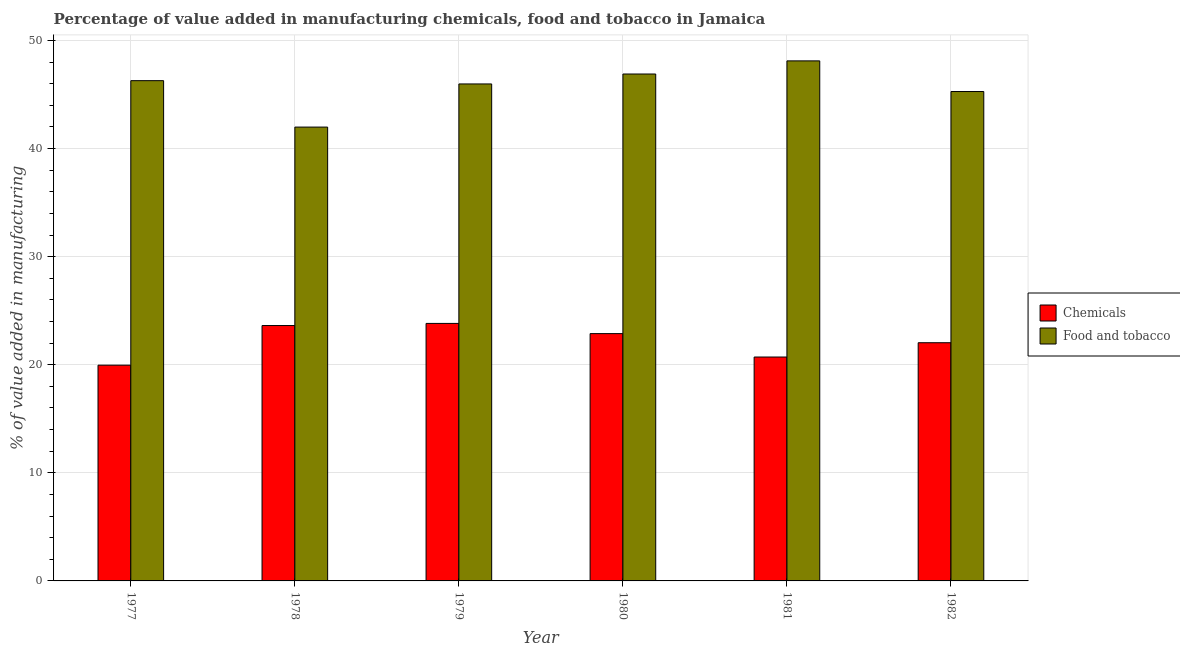How many different coloured bars are there?
Keep it short and to the point. 2. How many groups of bars are there?
Your response must be concise. 6. What is the value added by  manufacturing chemicals in 1982?
Ensure brevity in your answer.  22.03. Across all years, what is the maximum value added by  manufacturing chemicals?
Your answer should be compact. 23.82. Across all years, what is the minimum value added by  manufacturing chemicals?
Offer a very short reply. 19.96. In which year was the value added by  manufacturing chemicals maximum?
Provide a short and direct response. 1979. What is the total value added by manufacturing food and tobacco in the graph?
Offer a terse response. 274.51. What is the difference between the value added by manufacturing food and tobacco in 1979 and that in 1982?
Offer a very short reply. 0.7. What is the difference between the value added by  manufacturing chemicals in 1981 and the value added by manufacturing food and tobacco in 1980?
Give a very brief answer. -2.17. What is the average value added by  manufacturing chemicals per year?
Make the answer very short. 22.17. In the year 1978, what is the difference between the value added by manufacturing food and tobacco and value added by  manufacturing chemicals?
Your answer should be very brief. 0. What is the ratio of the value added by  manufacturing chemicals in 1979 to that in 1981?
Offer a very short reply. 1.15. Is the value added by  manufacturing chemicals in 1979 less than that in 1982?
Offer a very short reply. No. Is the difference between the value added by manufacturing food and tobacco in 1977 and 1980 greater than the difference between the value added by  manufacturing chemicals in 1977 and 1980?
Offer a terse response. No. What is the difference between the highest and the second highest value added by  manufacturing chemicals?
Your answer should be very brief. 0.2. What is the difference between the highest and the lowest value added by manufacturing food and tobacco?
Your response must be concise. 6.12. Is the sum of the value added by manufacturing food and tobacco in 1978 and 1979 greater than the maximum value added by  manufacturing chemicals across all years?
Your answer should be very brief. Yes. What does the 2nd bar from the left in 1980 represents?
Make the answer very short. Food and tobacco. What does the 2nd bar from the right in 1978 represents?
Your answer should be very brief. Chemicals. What is the difference between two consecutive major ticks on the Y-axis?
Your answer should be compact. 10. Does the graph contain grids?
Your answer should be compact. Yes. Where does the legend appear in the graph?
Make the answer very short. Center right. How are the legend labels stacked?
Offer a terse response. Vertical. What is the title of the graph?
Offer a very short reply. Percentage of value added in manufacturing chemicals, food and tobacco in Jamaica. What is the label or title of the Y-axis?
Ensure brevity in your answer.  % of value added in manufacturing. What is the % of value added in manufacturing in Chemicals in 1977?
Make the answer very short. 19.96. What is the % of value added in manufacturing of Food and tobacco in 1977?
Ensure brevity in your answer.  46.28. What is the % of value added in manufacturing of Chemicals in 1978?
Ensure brevity in your answer.  23.62. What is the % of value added in manufacturing of Food and tobacco in 1978?
Make the answer very short. 41.98. What is the % of value added in manufacturing in Chemicals in 1979?
Keep it short and to the point. 23.82. What is the % of value added in manufacturing in Food and tobacco in 1979?
Provide a short and direct response. 45.97. What is the % of value added in manufacturing in Chemicals in 1980?
Keep it short and to the point. 22.88. What is the % of value added in manufacturing of Food and tobacco in 1980?
Give a very brief answer. 46.89. What is the % of value added in manufacturing of Chemicals in 1981?
Offer a terse response. 20.71. What is the % of value added in manufacturing in Food and tobacco in 1981?
Ensure brevity in your answer.  48.11. What is the % of value added in manufacturing of Chemicals in 1982?
Offer a very short reply. 22.03. What is the % of value added in manufacturing in Food and tobacco in 1982?
Offer a very short reply. 45.27. Across all years, what is the maximum % of value added in manufacturing of Chemicals?
Offer a terse response. 23.82. Across all years, what is the maximum % of value added in manufacturing in Food and tobacco?
Offer a very short reply. 48.11. Across all years, what is the minimum % of value added in manufacturing in Chemicals?
Give a very brief answer. 19.96. Across all years, what is the minimum % of value added in manufacturing of Food and tobacco?
Ensure brevity in your answer.  41.98. What is the total % of value added in manufacturing of Chemicals in the graph?
Your response must be concise. 133.03. What is the total % of value added in manufacturing of Food and tobacco in the graph?
Give a very brief answer. 274.51. What is the difference between the % of value added in manufacturing in Chemicals in 1977 and that in 1978?
Your answer should be compact. -3.67. What is the difference between the % of value added in manufacturing in Food and tobacco in 1977 and that in 1978?
Give a very brief answer. 4.29. What is the difference between the % of value added in manufacturing of Chemicals in 1977 and that in 1979?
Your answer should be compact. -3.86. What is the difference between the % of value added in manufacturing of Food and tobacco in 1977 and that in 1979?
Your answer should be compact. 0.3. What is the difference between the % of value added in manufacturing in Chemicals in 1977 and that in 1980?
Ensure brevity in your answer.  -2.92. What is the difference between the % of value added in manufacturing of Food and tobacco in 1977 and that in 1980?
Provide a short and direct response. -0.62. What is the difference between the % of value added in manufacturing in Chemicals in 1977 and that in 1981?
Keep it short and to the point. -0.75. What is the difference between the % of value added in manufacturing of Food and tobacco in 1977 and that in 1981?
Keep it short and to the point. -1.83. What is the difference between the % of value added in manufacturing of Chemicals in 1977 and that in 1982?
Offer a very short reply. -2.07. What is the difference between the % of value added in manufacturing of Food and tobacco in 1977 and that in 1982?
Give a very brief answer. 1.01. What is the difference between the % of value added in manufacturing in Chemicals in 1978 and that in 1979?
Offer a very short reply. -0.2. What is the difference between the % of value added in manufacturing in Food and tobacco in 1978 and that in 1979?
Your answer should be compact. -3.99. What is the difference between the % of value added in manufacturing of Chemicals in 1978 and that in 1980?
Ensure brevity in your answer.  0.75. What is the difference between the % of value added in manufacturing of Food and tobacco in 1978 and that in 1980?
Your response must be concise. -4.91. What is the difference between the % of value added in manufacturing of Chemicals in 1978 and that in 1981?
Ensure brevity in your answer.  2.91. What is the difference between the % of value added in manufacturing of Food and tobacco in 1978 and that in 1981?
Provide a succinct answer. -6.12. What is the difference between the % of value added in manufacturing of Chemicals in 1978 and that in 1982?
Provide a short and direct response. 1.59. What is the difference between the % of value added in manufacturing in Food and tobacco in 1978 and that in 1982?
Offer a very short reply. -3.29. What is the difference between the % of value added in manufacturing of Chemicals in 1979 and that in 1980?
Your response must be concise. 0.94. What is the difference between the % of value added in manufacturing of Food and tobacco in 1979 and that in 1980?
Offer a very short reply. -0.92. What is the difference between the % of value added in manufacturing of Chemicals in 1979 and that in 1981?
Your answer should be very brief. 3.11. What is the difference between the % of value added in manufacturing of Food and tobacco in 1979 and that in 1981?
Your answer should be very brief. -2.13. What is the difference between the % of value added in manufacturing in Chemicals in 1979 and that in 1982?
Offer a very short reply. 1.79. What is the difference between the % of value added in manufacturing of Food and tobacco in 1979 and that in 1982?
Provide a succinct answer. 0.7. What is the difference between the % of value added in manufacturing of Chemicals in 1980 and that in 1981?
Your answer should be very brief. 2.17. What is the difference between the % of value added in manufacturing in Food and tobacco in 1980 and that in 1981?
Offer a terse response. -1.21. What is the difference between the % of value added in manufacturing in Chemicals in 1980 and that in 1982?
Offer a very short reply. 0.84. What is the difference between the % of value added in manufacturing of Food and tobacco in 1980 and that in 1982?
Offer a very short reply. 1.62. What is the difference between the % of value added in manufacturing of Chemicals in 1981 and that in 1982?
Ensure brevity in your answer.  -1.32. What is the difference between the % of value added in manufacturing of Food and tobacco in 1981 and that in 1982?
Ensure brevity in your answer.  2.84. What is the difference between the % of value added in manufacturing in Chemicals in 1977 and the % of value added in manufacturing in Food and tobacco in 1978?
Offer a terse response. -22.02. What is the difference between the % of value added in manufacturing in Chemicals in 1977 and the % of value added in manufacturing in Food and tobacco in 1979?
Ensure brevity in your answer.  -26.02. What is the difference between the % of value added in manufacturing in Chemicals in 1977 and the % of value added in manufacturing in Food and tobacco in 1980?
Offer a very short reply. -26.93. What is the difference between the % of value added in manufacturing in Chemicals in 1977 and the % of value added in manufacturing in Food and tobacco in 1981?
Your answer should be very brief. -28.15. What is the difference between the % of value added in manufacturing in Chemicals in 1977 and the % of value added in manufacturing in Food and tobacco in 1982?
Your response must be concise. -25.31. What is the difference between the % of value added in manufacturing in Chemicals in 1978 and the % of value added in manufacturing in Food and tobacco in 1979?
Offer a very short reply. -22.35. What is the difference between the % of value added in manufacturing in Chemicals in 1978 and the % of value added in manufacturing in Food and tobacco in 1980?
Give a very brief answer. -23.27. What is the difference between the % of value added in manufacturing in Chemicals in 1978 and the % of value added in manufacturing in Food and tobacco in 1981?
Give a very brief answer. -24.48. What is the difference between the % of value added in manufacturing of Chemicals in 1978 and the % of value added in manufacturing of Food and tobacco in 1982?
Keep it short and to the point. -21.65. What is the difference between the % of value added in manufacturing in Chemicals in 1979 and the % of value added in manufacturing in Food and tobacco in 1980?
Provide a succinct answer. -23.07. What is the difference between the % of value added in manufacturing of Chemicals in 1979 and the % of value added in manufacturing of Food and tobacco in 1981?
Make the answer very short. -24.29. What is the difference between the % of value added in manufacturing of Chemicals in 1979 and the % of value added in manufacturing of Food and tobacco in 1982?
Your response must be concise. -21.45. What is the difference between the % of value added in manufacturing in Chemicals in 1980 and the % of value added in manufacturing in Food and tobacco in 1981?
Ensure brevity in your answer.  -25.23. What is the difference between the % of value added in manufacturing of Chemicals in 1980 and the % of value added in manufacturing of Food and tobacco in 1982?
Offer a very short reply. -22.4. What is the difference between the % of value added in manufacturing in Chemicals in 1981 and the % of value added in manufacturing in Food and tobacco in 1982?
Keep it short and to the point. -24.56. What is the average % of value added in manufacturing in Chemicals per year?
Offer a terse response. 22.17. What is the average % of value added in manufacturing in Food and tobacco per year?
Provide a short and direct response. 45.75. In the year 1977, what is the difference between the % of value added in manufacturing in Chemicals and % of value added in manufacturing in Food and tobacco?
Your response must be concise. -26.32. In the year 1978, what is the difference between the % of value added in manufacturing of Chemicals and % of value added in manufacturing of Food and tobacco?
Offer a very short reply. -18.36. In the year 1979, what is the difference between the % of value added in manufacturing in Chemicals and % of value added in manufacturing in Food and tobacco?
Keep it short and to the point. -22.15. In the year 1980, what is the difference between the % of value added in manufacturing of Chemicals and % of value added in manufacturing of Food and tobacco?
Offer a terse response. -24.02. In the year 1981, what is the difference between the % of value added in manufacturing of Chemicals and % of value added in manufacturing of Food and tobacco?
Provide a succinct answer. -27.4. In the year 1982, what is the difference between the % of value added in manufacturing of Chemicals and % of value added in manufacturing of Food and tobacco?
Make the answer very short. -23.24. What is the ratio of the % of value added in manufacturing in Chemicals in 1977 to that in 1978?
Offer a very short reply. 0.84. What is the ratio of the % of value added in manufacturing of Food and tobacco in 1977 to that in 1978?
Your response must be concise. 1.1. What is the ratio of the % of value added in manufacturing of Chemicals in 1977 to that in 1979?
Your response must be concise. 0.84. What is the ratio of the % of value added in manufacturing of Food and tobacco in 1977 to that in 1979?
Ensure brevity in your answer.  1.01. What is the ratio of the % of value added in manufacturing of Chemicals in 1977 to that in 1980?
Offer a terse response. 0.87. What is the ratio of the % of value added in manufacturing of Food and tobacco in 1977 to that in 1980?
Give a very brief answer. 0.99. What is the ratio of the % of value added in manufacturing of Chemicals in 1977 to that in 1981?
Your answer should be very brief. 0.96. What is the ratio of the % of value added in manufacturing in Food and tobacco in 1977 to that in 1981?
Give a very brief answer. 0.96. What is the ratio of the % of value added in manufacturing of Chemicals in 1977 to that in 1982?
Provide a succinct answer. 0.91. What is the ratio of the % of value added in manufacturing in Food and tobacco in 1977 to that in 1982?
Provide a succinct answer. 1.02. What is the ratio of the % of value added in manufacturing in Chemicals in 1978 to that in 1979?
Provide a short and direct response. 0.99. What is the ratio of the % of value added in manufacturing of Food and tobacco in 1978 to that in 1979?
Ensure brevity in your answer.  0.91. What is the ratio of the % of value added in manufacturing of Chemicals in 1978 to that in 1980?
Ensure brevity in your answer.  1.03. What is the ratio of the % of value added in manufacturing of Food and tobacco in 1978 to that in 1980?
Make the answer very short. 0.9. What is the ratio of the % of value added in manufacturing in Chemicals in 1978 to that in 1981?
Make the answer very short. 1.14. What is the ratio of the % of value added in manufacturing in Food and tobacco in 1978 to that in 1981?
Your answer should be compact. 0.87. What is the ratio of the % of value added in manufacturing of Chemicals in 1978 to that in 1982?
Your answer should be compact. 1.07. What is the ratio of the % of value added in manufacturing in Food and tobacco in 1978 to that in 1982?
Your response must be concise. 0.93. What is the ratio of the % of value added in manufacturing of Chemicals in 1979 to that in 1980?
Keep it short and to the point. 1.04. What is the ratio of the % of value added in manufacturing in Food and tobacco in 1979 to that in 1980?
Make the answer very short. 0.98. What is the ratio of the % of value added in manufacturing in Chemicals in 1979 to that in 1981?
Offer a very short reply. 1.15. What is the ratio of the % of value added in manufacturing in Food and tobacco in 1979 to that in 1981?
Your answer should be compact. 0.96. What is the ratio of the % of value added in manufacturing of Chemicals in 1979 to that in 1982?
Give a very brief answer. 1.08. What is the ratio of the % of value added in manufacturing in Food and tobacco in 1979 to that in 1982?
Your response must be concise. 1.02. What is the ratio of the % of value added in manufacturing in Chemicals in 1980 to that in 1981?
Keep it short and to the point. 1.1. What is the ratio of the % of value added in manufacturing of Food and tobacco in 1980 to that in 1981?
Offer a very short reply. 0.97. What is the ratio of the % of value added in manufacturing in Chemicals in 1980 to that in 1982?
Offer a terse response. 1.04. What is the ratio of the % of value added in manufacturing of Food and tobacco in 1980 to that in 1982?
Offer a terse response. 1.04. What is the ratio of the % of value added in manufacturing in Food and tobacco in 1981 to that in 1982?
Your response must be concise. 1.06. What is the difference between the highest and the second highest % of value added in manufacturing in Chemicals?
Provide a succinct answer. 0.2. What is the difference between the highest and the second highest % of value added in manufacturing in Food and tobacco?
Make the answer very short. 1.21. What is the difference between the highest and the lowest % of value added in manufacturing in Chemicals?
Your answer should be very brief. 3.86. What is the difference between the highest and the lowest % of value added in manufacturing of Food and tobacco?
Provide a succinct answer. 6.12. 